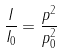Convert formula to latex. <formula><loc_0><loc_0><loc_500><loc_500>\frac { I } { I _ { 0 } } = \frac { p ^ { 2 } } { p _ { 0 } ^ { 2 } }</formula> 